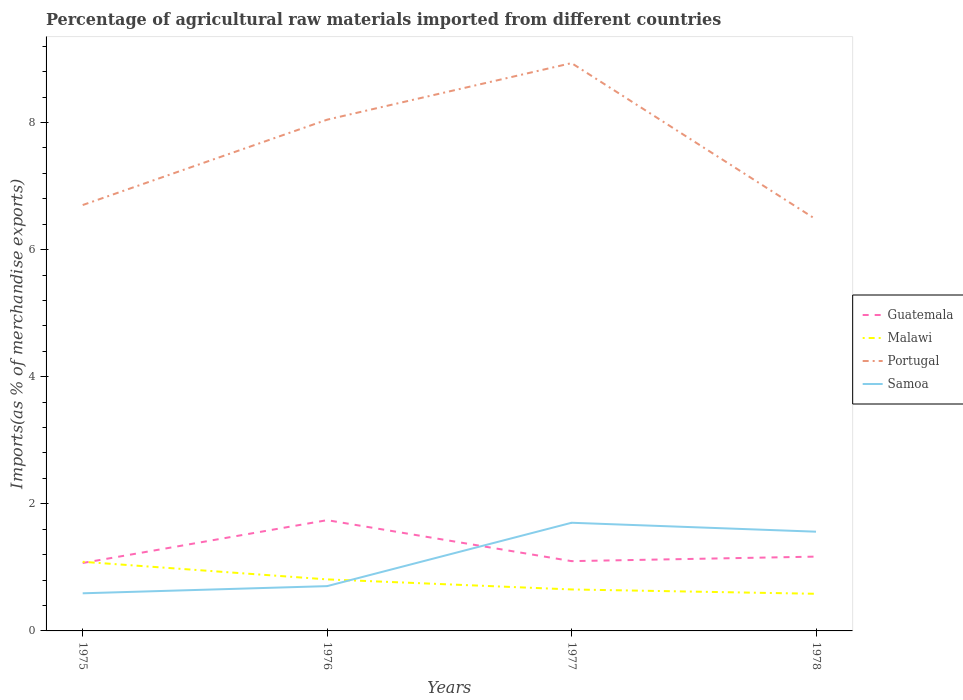How many different coloured lines are there?
Provide a succinct answer. 4. Does the line corresponding to Portugal intersect with the line corresponding to Guatemala?
Keep it short and to the point. No. Across all years, what is the maximum percentage of imports to different countries in Portugal?
Give a very brief answer. 6.47. In which year was the percentage of imports to different countries in Portugal maximum?
Give a very brief answer. 1978. What is the total percentage of imports to different countries in Guatemala in the graph?
Your response must be concise. -0.03. What is the difference between the highest and the second highest percentage of imports to different countries in Malawi?
Ensure brevity in your answer.  0.5. What is the difference between the highest and the lowest percentage of imports to different countries in Portugal?
Your response must be concise. 2. What is the difference between two consecutive major ticks on the Y-axis?
Your answer should be compact. 2. Does the graph contain any zero values?
Provide a succinct answer. No. Does the graph contain grids?
Your response must be concise. No. Where does the legend appear in the graph?
Your response must be concise. Center right. How are the legend labels stacked?
Offer a terse response. Vertical. What is the title of the graph?
Give a very brief answer. Percentage of agricultural raw materials imported from different countries. Does "Thailand" appear as one of the legend labels in the graph?
Your answer should be very brief. No. What is the label or title of the X-axis?
Offer a very short reply. Years. What is the label or title of the Y-axis?
Your answer should be compact. Imports(as % of merchandise exports). What is the Imports(as % of merchandise exports) of Guatemala in 1975?
Your answer should be very brief. 1.07. What is the Imports(as % of merchandise exports) of Malawi in 1975?
Offer a terse response. 1.09. What is the Imports(as % of merchandise exports) of Portugal in 1975?
Offer a very short reply. 6.7. What is the Imports(as % of merchandise exports) in Samoa in 1975?
Provide a succinct answer. 0.59. What is the Imports(as % of merchandise exports) in Guatemala in 1976?
Ensure brevity in your answer.  1.74. What is the Imports(as % of merchandise exports) in Malawi in 1976?
Provide a short and direct response. 0.81. What is the Imports(as % of merchandise exports) in Portugal in 1976?
Ensure brevity in your answer.  8.04. What is the Imports(as % of merchandise exports) of Samoa in 1976?
Keep it short and to the point. 0.7. What is the Imports(as % of merchandise exports) in Guatemala in 1977?
Ensure brevity in your answer.  1.1. What is the Imports(as % of merchandise exports) in Malawi in 1977?
Ensure brevity in your answer.  0.65. What is the Imports(as % of merchandise exports) in Portugal in 1977?
Give a very brief answer. 8.93. What is the Imports(as % of merchandise exports) of Samoa in 1977?
Keep it short and to the point. 1.7. What is the Imports(as % of merchandise exports) in Guatemala in 1978?
Give a very brief answer. 1.17. What is the Imports(as % of merchandise exports) in Malawi in 1978?
Give a very brief answer. 0.58. What is the Imports(as % of merchandise exports) of Portugal in 1978?
Offer a terse response. 6.47. What is the Imports(as % of merchandise exports) in Samoa in 1978?
Give a very brief answer. 1.56. Across all years, what is the maximum Imports(as % of merchandise exports) in Guatemala?
Provide a short and direct response. 1.74. Across all years, what is the maximum Imports(as % of merchandise exports) in Malawi?
Keep it short and to the point. 1.09. Across all years, what is the maximum Imports(as % of merchandise exports) in Portugal?
Give a very brief answer. 8.93. Across all years, what is the maximum Imports(as % of merchandise exports) of Samoa?
Make the answer very short. 1.7. Across all years, what is the minimum Imports(as % of merchandise exports) of Guatemala?
Make the answer very short. 1.07. Across all years, what is the minimum Imports(as % of merchandise exports) in Malawi?
Provide a succinct answer. 0.58. Across all years, what is the minimum Imports(as % of merchandise exports) in Portugal?
Your answer should be compact. 6.47. Across all years, what is the minimum Imports(as % of merchandise exports) of Samoa?
Ensure brevity in your answer.  0.59. What is the total Imports(as % of merchandise exports) in Guatemala in the graph?
Ensure brevity in your answer.  5.08. What is the total Imports(as % of merchandise exports) of Malawi in the graph?
Keep it short and to the point. 3.14. What is the total Imports(as % of merchandise exports) of Portugal in the graph?
Provide a short and direct response. 30.15. What is the total Imports(as % of merchandise exports) of Samoa in the graph?
Offer a very short reply. 4.56. What is the difference between the Imports(as % of merchandise exports) in Guatemala in 1975 and that in 1976?
Provide a succinct answer. -0.67. What is the difference between the Imports(as % of merchandise exports) in Malawi in 1975 and that in 1976?
Make the answer very short. 0.28. What is the difference between the Imports(as % of merchandise exports) of Portugal in 1975 and that in 1976?
Give a very brief answer. -1.34. What is the difference between the Imports(as % of merchandise exports) in Samoa in 1975 and that in 1976?
Your response must be concise. -0.11. What is the difference between the Imports(as % of merchandise exports) of Guatemala in 1975 and that in 1977?
Make the answer very short. -0.03. What is the difference between the Imports(as % of merchandise exports) of Malawi in 1975 and that in 1977?
Ensure brevity in your answer.  0.44. What is the difference between the Imports(as % of merchandise exports) in Portugal in 1975 and that in 1977?
Make the answer very short. -2.23. What is the difference between the Imports(as % of merchandise exports) of Samoa in 1975 and that in 1977?
Your response must be concise. -1.11. What is the difference between the Imports(as % of merchandise exports) in Guatemala in 1975 and that in 1978?
Provide a succinct answer. -0.1. What is the difference between the Imports(as % of merchandise exports) in Malawi in 1975 and that in 1978?
Offer a terse response. 0.5. What is the difference between the Imports(as % of merchandise exports) in Portugal in 1975 and that in 1978?
Provide a short and direct response. 0.23. What is the difference between the Imports(as % of merchandise exports) of Samoa in 1975 and that in 1978?
Offer a terse response. -0.97. What is the difference between the Imports(as % of merchandise exports) of Guatemala in 1976 and that in 1977?
Your answer should be compact. 0.64. What is the difference between the Imports(as % of merchandise exports) in Malawi in 1976 and that in 1977?
Provide a short and direct response. 0.16. What is the difference between the Imports(as % of merchandise exports) of Portugal in 1976 and that in 1977?
Provide a succinct answer. -0.89. What is the difference between the Imports(as % of merchandise exports) of Samoa in 1976 and that in 1977?
Provide a succinct answer. -1. What is the difference between the Imports(as % of merchandise exports) of Guatemala in 1976 and that in 1978?
Provide a succinct answer. 0.57. What is the difference between the Imports(as % of merchandise exports) of Malawi in 1976 and that in 1978?
Give a very brief answer. 0.23. What is the difference between the Imports(as % of merchandise exports) in Portugal in 1976 and that in 1978?
Offer a very short reply. 1.57. What is the difference between the Imports(as % of merchandise exports) of Samoa in 1976 and that in 1978?
Your answer should be compact. -0.86. What is the difference between the Imports(as % of merchandise exports) of Guatemala in 1977 and that in 1978?
Provide a succinct answer. -0.07. What is the difference between the Imports(as % of merchandise exports) in Malawi in 1977 and that in 1978?
Ensure brevity in your answer.  0.07. What is the difference between the Imports(as % of merchandise exports) in Portugal in 1977 and that in 1978?
Your answer should be very brief. 2.46. What is the difference between the Imports(as % of merchandise exports) in Samoa in 1977 and that in 1978?
Keep it short and to the point. 0.14. What is the difference between the Imports(as % of merchandise exports) in Guatemala in 1975 and the Imports(as % of merchandise exports) in Malawi in 1976?
Your response must be concise. 0.26. What is the difference between the Imports(as % of merchandise exports) of Guatemala in 1975 and the Imports(as % of merchandise exports) of Portugal in 1976?
Offer a very short reply. -6.98. What is the difference between the Imports(as % of merchandise exports) of Guatemala in 1975 and the Imports(as % of merchandise exports) of Samoa in 1976?
Provide a succinct answer. 0.36. What is the difference between the Imports(as % of merchandise exports) in Malawi in 1975 and the Imports(as % of merchandise exports) in Portugal in 1976?
Your response must be concise. -6.96. What is the difference between the Imports(as % of merchandise exports) of Malawi in 1975 and the Imports(as % of merchandise exports) of Samoa in 1976?
Your answer should be very brief. 0.38. What is the difference between the Imports(as % of merchandise exports) of Portugal in 1975 and the Imports(as % of merchandise exports) of Samoa in 1976?
Offer a terse response. 6. What is the difference between the Imports(as % of merchandise exports) in Guatemala in 1975 and the Imports(as % of merchandise exports) in Malawi in 1977?
Offer a terse response. 0.42. What is the difference between the Imports(as % of merchandise exports) of Guatemala in 1975 and the Imports(as % of merchandise exports) of Portugal in 1977?
Provide a succinct answer. -7.87. What is the difference between the Imports(as % of merchandise exports) in Guatemala in 1975 and the Imports(as % of merchandise exports) in Samoa in 1977?
Give a very brief answer. -0.63. What is the difference between the Imports(as % of merchandise exports) in Malawi in 1975 and the Imports(as % of merchandise exports) in Portugal in 1977?
Offer a very short reply. -7.85. What is the difference between the Imports(as % of merchandise exports) of Malawi in 1975 and the Imports(as % of merchandise exports) of Samoa in 1977?
Give a very brief answer. -0.61. What is the difference between the Imports(as % of merchandise exports) in Portugal in 1975 and the Imports(as % of merchandise exports) in Samoa in 1977?
Ensure brevity in your answer.  5. What is the difference between the Imports(as % of merchandise exports) of Guatemala in 1975 and the Imports(as % of merchandise exports) of Malawi in 1978?
Provide a short and direct response. 0.48. What is the difference between the Imports(as % of merchandise exports) in Guatemala in 1975 and the Imports(as % of merchandise exports) in Portugal in 1978?
Give a very brief answer. -5.41. What is the difference between the Imports(as % of merchandise exports) in Guatemala in 1975 and the Imports(as % of merchandise exports) in Samoa in 1978?
Provide a succinct answer. -0.49. What is the difference between the Imports(as % of merchandise exports) in Malawi in 1975 and the Imports(as % of merchandise exports) in Portugal in 1978?
Your response must be concise. -5.39. What is the difference between the Imports(as % of merchandise exports) of Malawi in 1975 and the Imports(as % of merchandise exports) of Samoa in 1978?
Offer a terse response. -0.47. What is the difference between the Imports(as % of merchandise exports) in Portugal in 1975 and the Imports(as % of merchandise exports) in Samoa in 1978?
Provide a short and direct response. 5.14. What is the difference between the Imports(as % of merchandise exports) of Guatemala in 1976 and the Imports(as % of merchandise exports) of Malawi in 1977?
Your response must be concise. 1.09. What is the difference between the Imports(as % of merchandise exports) of Guatemala in 1976 and the Imports(as % of merchandise exports) of Portugal in 1977?
Provide a short and direct response. -7.19. What is the difference between the Imports(as % of merchandise exports) of Guatemala in 1976 and the Imports(as % of merchandise exports) of Samoa in 1977?
Give a very brief answer. 0.04. What is the difference between the Imports(as % of merchandise exports) in Malawi in 1976 and the Imports(as % of merchandise exports) in Portugal in 1977?
Give a very brief answer. -8.12. What is the difference between the Imports(as % of merchandise exports) of Malawi in 1976 and the Imports(as % of merchandise exports) of Samoa in 1977?
Your answer should be very brief. -0.89. What is the difference between the Imports(as % of merchandise exports) of Portugal in 1976 and the Imports(as % of merchandise exports) of Samoa in 1977?
Offer a very short reply. 6.34. What is the difference between the Imports(as % of merchandise exports) in Guatemala in 1976 and the Imports(as % of merchandise exports) in Malawi in 1978?
Keep it short and to the point. 1.16. What is the difference between the Imports(as % of merchandise exports) of Guatemala in 1976 and the Imports(as % of merchandise exports) of Portugal in 1978?
Your answer should be compact. -4.73. What is the difference between the Imports(as % of merchandise exports) of Guatemala in 1976 and the Imports(as % of merchandise exports) of Samoa in 1978?
Offer a terse response. 0.18. What is the difference between the Imports(as % of merchandise exports) in Malawi in 1976 and the Imports(as % of merchandise exports) in Portugal in 1978?
Provide a succinct answer. -5.66. What is the difference between the Imports(as % of merchandise exports) in Malawi in 1976 and the Imports(as % of merchandise exports) in Samoa in 1978?
Offer a very short reply. -0.75. What is the difference between the Imports(as % of merchandise exports) of Portugal in 1976 and the Imports(as % of merchandise exports) of Samoa in 1978?
Your answer should be compact. 6.48. What is the difference between the Imports(as % of merchandise exports) in Guatemala in 1977 and the Imports(as % of merchandise exports) in Malawi in 1978?
Offer a terse response. 0.51. What is the difference between the Imports(as % of merchandise exports) in Guatemala in 1977 and the Imports(as % of merchandise exports) in Portugal in 1978?
Give a very brief answer. -5.38. What is the difference between the Imports(as % of merchandise exports) in Guatemala in 1977 and the Imports(as % of merchandise exports) in Samoa in 1978?
Your answer should be compact. -0.46. What is the difference between the Imports(as % of merchandise exports) in Malawi in 1977 and the Imports(as % of merchandise exports) in Portugal in 1978?
Keep it short and to the point. -5.82. What is the difference between the Imports(as % of merchandise exports) in Malawi in 1977 and the Imports(as % of merchandise exports) in Samoa in 1978?
Offer a terse response. -0.91. What is the difference between the Imports(as % of merchandise exports) of Portugal in 1977 and the Imports(as % of merchandise exports) of Samoa in 1978?
Provide a short and direct response. 7.37. What is the average Imports(as % of merchandise exports) in Guatemala per year?
Your answer should be very brief. 1.27. What is the average Imports(as % of merchandise exports) of Malawi per year?
Provide a short and direct response. 0.78. What is the average Imports(as % of merchandise exports) in Portugal per year?
Make the answer very short. 7.54. What is the average Imports(as % of merchandise exports) in Samoa per year?
Give a very brief answer. 1.14. In the year 1975, what is the difference between the Imports(as % of merchandise exports) of Guatemala and Imports(as % of merchandise exports) of Malawi?
Make the answer very short. -0.02. In the year 1975, what is the difference between the Imports(as % of merchandise exports) of Guatemala and Imports(as % of merchandise exports) of Portugal?
Offer a terse response. -5.63. In the year 1975, what is the difference between the Imports(as % of merchandise exports) of Guatemala and Imports(as % of merchandise exports) of Samoa?
Keep it short and to the point. 0.48. In the year 1975, what is the difference between the Imports(as % of merchandise exports) of Malawi and Imports(as % of merchandise exports) of Portugal?
Offer a very short reply. -5.61. In the year 1975, what is the difference between the Imports(as % of merchandise exports) in Malawi and Imports(as % of merchandise exports) in Samoa?
Ensure brevity in your answer.  0.5. In the year 1975, what is the difference between the Imports(as % of merchandise exports) of Portugal and Imports(as % of merchandise exports) of Samoa?
Provide a short and direct response. 6.11. In the year 1976, what is the difference between the Imports(as % of merchandise exports) in Guatemala and Imports(as % of merchandise exports) in Malawi?
Provide a short and direct response. 0.93. In the year 1976, what is the difference between the Imports(as % of merchandise exports) in Guatemala and Imports(as % of merchandise exports) in Portugal?
Provide a succinct answer. -6.3. In the year 1976, what is the difference between the Imports(as % of merchandise exports) in Guatemala and Imports(as % of merchandise exports) in Samoa?
Provide a short and direct response. 1.04. In the year 1976, what is the difference between the Imports(as % of merchandise exports) of Malawi and Imports(as % of merchandise exports) of Portugal?
Offer a terse response. -7.23. In the year 1976, what is the difference between the Imports(as % of merchandise exports) of Malawi and Imports(as % of merchandise exports) of Samoa?
Ensure brevity in your answer.  0.11. In the year 1976, what is the difference between the Imports(as % of merchandise exports) in Portugal and Imports(as % of merchandise exports) in Samoa?
Ensure brevity in your answer.  7.34. In the year 1977, what is the difference between the Imports(as % of merchandise exports) of Guatemala and Imports(as % of merchandise exports) of Malawi?
Offer a terse response. 0.45. In the year 1977, what is the difference between the Imports(as % of merchandise exports) of Guatemala and Imports(as % of merchandise exports) of Portugal?
Your answer should be compact. -7.84. In the year 1977, what is the difference between the Imports(as % of merchandise exports) of Guatemala and Imports(as % of merchandise exports) of Samoa?
Give a very brief answer. -0.6. In the year 1977, what is the difference between the Imports(as % of merchandise exports) of Malawi and Imports(as % of merchandise exports) of Portugal?
Keep it short and to the point. -8.28. In the year 1977, what is the difference between the Imports(as % of merchandise exports) of Malawi and Imports(as % of merchandise exports) of Samoa?
Offer a terse response. -1.05. In the year 1977, what is the difference between the Imports(as % of merchandise exports) in Portugal and Imports(as % of merchandise exports) in Samoa?
Your answer should be compact. 7.23. In the year 1978, what is the difference between the Imports(as % of merchandise exports) in Guatemala and Imports(as % of merchandise exports) in Malawi?
Your answer should be very brief. 0.58. In the year 1978, what is the difference between the Imports(as % of merchandise exports) in Guatemala and Imports(as % of merchandise exports) in Portugal?
Give a very brief answer. -5.31. In the year 1978, what is the difference between the Imports(as % of merchandise exports) of Guatemala and Imports(as % of merchandise exports) of Samoa?
Give a very brief answer. -0.39. In the year 1978, what is the difference between the Imports(as % of merchandise exports) of Malawi and Imports(as % of merchandise exports) of Portugal?
Your response must be concise. -5.89. In the year 1978, what is the difference between the Imports(as % of merchandise exports) of Malawi and Imports(as % of merchandise exports) of Samoa?
Make the answer very short. -0.98. In the year 1978, what is the difference between the Imports(as % of merchandise exports) of Portugal and Imports(as % of merchandise exports) of Samoa?
Keep it short and to the point. 4.91. What is the ratio of the Imports(as % of merchandise exports) in Guatemala in 1975 to that in 1976?
Your answer should be compact. 0.61. What is the ratio of the Imports(as % of merchandise exports) in Malawi in 1975 to that in 1976?
Your response must be concise. 1.34. What is the ratio of the Imports(as % of merchandise exports) in Portugal in 1975 to that in 1976?
Give a very brief answer. 0.83. What is the ratio of the Imports(as % of merchandise exports) in Samoa in 1975 to that in 1976?
Keep it short and to the point. 0.84. What is the ratio of the Imports(as % of merchandise exports) of Guatemala in 1975 to that in 1977?
Your response must be concise. 0.97. What is the ratio of the Imports(as % of merchandise exports) in Malawi in 1975 to that in 1977?
Your answer should be compact. 1.67. What is the ratio of the Imports(as % of merchandise exports) in Portugal in 1975 to that in 1977?
Keep it short and to the point. 0.75. What is the ratio of the Imports(as % of merchandise exports) in Samoa in 1975 to that in 1977?
Ensure brevity in your answer.  0.35. What is the ratio of the Imports(as % of merchandise exports) in Guatemala in 1975 to that in 1978?
Offer a very short reply. 0.91. What is the ratio of the Imports(as % of merchandise exports) of Malawi in 1975 to that in 1978?
Provide a short and direct response. 1.86. What is the ratio of the Imports(as % of merchandise exports) in Portugal in 1975 to that in 1978?
Make the answer very short. 1.03. What is the ratio of the Imports(as % of merchandise exports) of Samoa in 1975 to that in 1978?
Offer a very short reply. 0.38. What is the ratio of the Imports(as % of merchandise exports) in Guatemala in 1976 to that in 1977?
Offer a very short reply. 1.59. What is the ratio of the Imports(as % of merchandise exports) of Malawi in 1976 to that in 1977?
Offer a terse response. 1.24. What is the ratio of the Imports(as % of merchandise exports) of Portugal in 1976 to that in 1977?
Ensure brevity in your answer.  0.9. What is the ratio of the Imports(as % of merchandise exports) in Samoa in 1976 to that in 1977?
Offer a very short reply. 0.41. What is the ratio of the Imports(as % of merchandise exports) in Guatemala in 1976 to that in 1978?
Keep it short and to the point. 1.49. What is the ratio of the Imports(as % of merchandise exports) in Malawi in 1976 to that in 1978?
Your response must be concise. 1.39. What is the ratio of the Imports(as % of merchandise exports) in Portugal in 1976 to that in 1978?
Ensure brevity in your answer.  1.24. What is the ratio of the Imports(as % of merchandise exports) of Samoa in 1976 to that in 1978?
Your answer should be compact. 0.45. What is the ratio of the Imports(as % of merchandise exports) of Guatemala in 1977 to that in 1978?
Your answer should be compact. 0.94. What is the ratio of the Imports(as % of merchandise exports) in Malawi in 1977 to that in 1978?
Your response must be concise. 1.12. What is the ratio of the Imports(as % of merchandise exports) in Portugal in 1977 to that in 1978?
Make the answer very short. 1.38. What is the ratio of the Imports(as % of merchandise exports) in Samoa in 1977 to that in 1978?
Your answer should be very brief. 1.09. What is the difference between the highest and the second highest Imports(as % of merchandise exports) of Guatemala?
Provide a succinct answer. 0.57. What is the difference between the highest and the second highest Imports(as % of merchandise exports) in Malawi?
Ensure brevity in your answer.  0.28. What is the difference between the highest and the second highest Imports(as % of merchandise exports) of Portugal?
Offer a very short reply. 0.89. What is the difference between the highest and the second highest Imports(as % of merchandise exports) in Samoa?
Make the answer very short. 0.14. What is the difference between the highest and the lowest Imports(as % of merchandise exports) in Guatemala?
Your answer should be very brief. 0.67. What is the difference between the highest and the lowest Imports(as % of merchandise exports) in Malawi?
Your answer should be very brief. 0.5. What is the difference between the highest and the lowest Imports(as % of merchandise exports) in Portugal?
Your response must be concise. 2.46. What is the difference between the highest and the lowest Imports(as % of merchandise exports) in Samoa?
Your answer should be very brief. 1.11. 